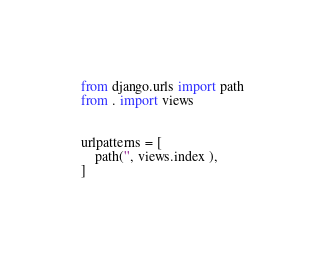Convert code to text. <code><loc_0><loc_0><loc_500><loc_500><_Python_>from django.urls import path
from . import views


urlpatterns = [
    path('', views.index ),
]
</code> 